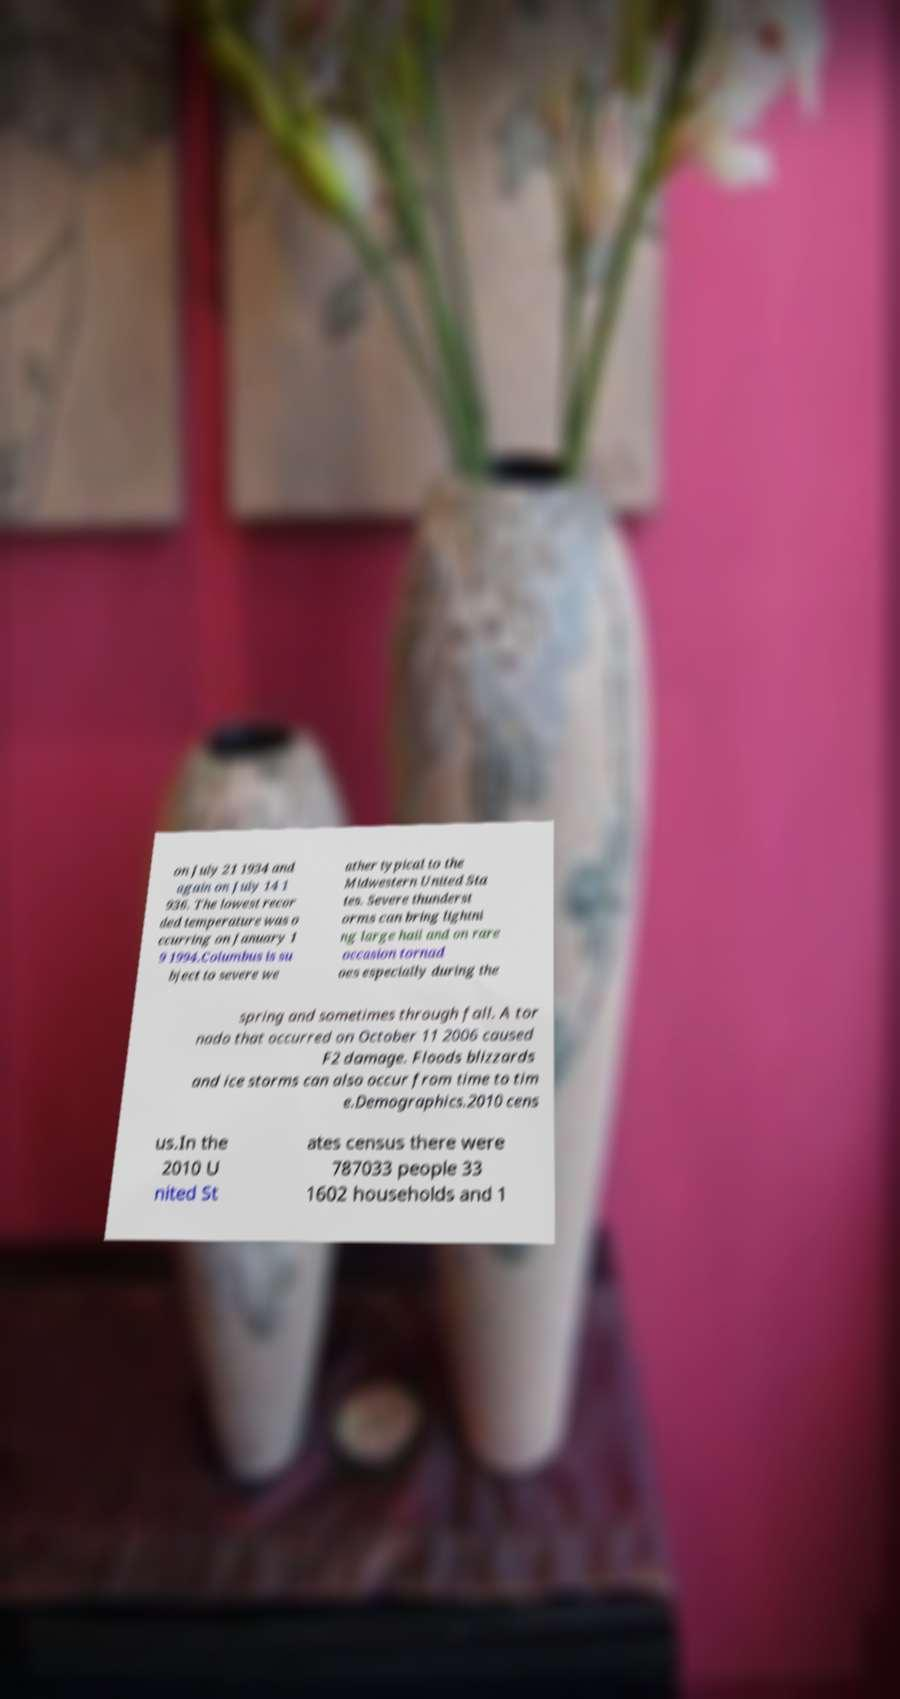Please read and relay the text visible in this image. What does it say? on July 21 1934 and again on July 14 1 936. The lowest recor ded temperature was o ccurring on January 1 9 1994.Columbus is su bject to severe we ather typical to the Midwestern United Sta tes. Severe thunderst orms can bring lightni ng large hail and on rare occasion tornad oes especially during the spring and sometimes through fall. A tor nado that occurred on October 11 2006 caused F2 damage. Floods blizzards and ice storms can also occur from time to tim e.Demographics.2010 cens us.In the 2010 U nited St ates census there were 787033 people 33 1602 households and 1 